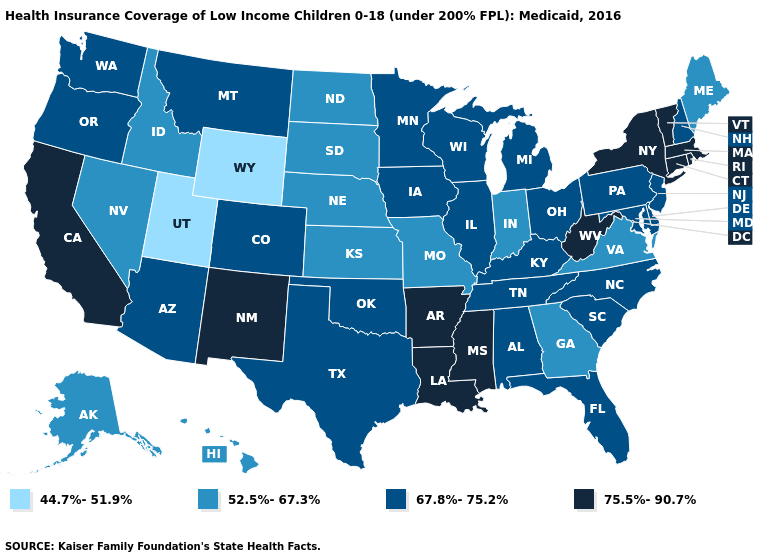What is the lowest value in the USA?
Quick response, please. 44.7%-51.9%. What is the value of Florida?
Concise answer only. 67.8%-75.2%. Which states hav the highest value in the South?
Give a very brief answer. Arkansas, Louisiana, Mississippi, West Virginia. Is the legend a continuous bar?
Short answer required. No. Name the states that have a value in the range 52.5%-67.3%?
Answer briefly. Alaska, Georgia, Hawaii, Idaho, Indiana, Kansas, Maine, Missouri, Nebraska, Nevada, North Dakota, South Dakota, Virginia. What is the highest value in states that border Texas?
Answer briefly. 75.5%-90.7%. What is the highest value in the USA?
Short answer required. 75.5%-90.7%. What is the value of Tennessee?
Give a very brief answer. 67.8%-75.2%. Does New Mexico have the lowest value in the USA?
Concise answer only. No. Among the states that border South Carolina , does North Carolina have the highest value?
Be succinct. Yes. Which states have the lowest value in the West?
Keep it brief. Utah, Wyoming. Does West Virginia have the lowest value in the South?
Concise answer only. No. Does Kentucky have a higher value than Texas?
Keep it brief. No. Which states hav the highest value in the West?
Concise answer only. California, New Mexico. Name the states that have a value in the range 67.8%-75.2%?
Quick response, please. Alabama, Arizona, Colorado, Delaware, Florida, Illinois, Iowa, Kentucky, Maryland, Michigan, Minnesota, Montana, New Hampshire, New Jersey, North Carolina, Ohio, Oklahoma, Oregon, Pennsylvania, South Carolina, Tennessee, Texas, Washington, Wisconsin. 